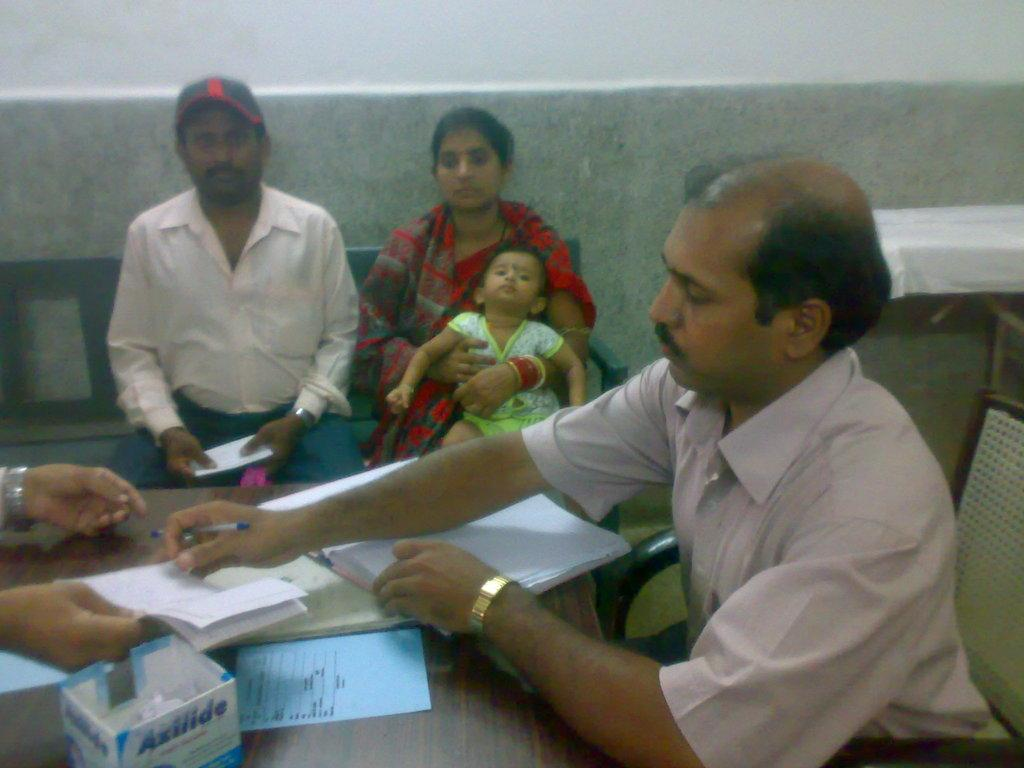What is the man in the image doing? The man is sitting on a chair in the image. Who else is sitting in the image? There is a couple sitting on a bench in the image. Are there any children in the image? Yes, there is a child in the image. What can be seen on the wall in the image? There is a paper on the wall in the image. What is on the table in the image? There is a book on a table in the image. What object related to writing is present in the image? There is a pen in the image. What type of vest is the scarecrow wearing in the image? There is no scarecrow present in the image, so it is not possible to determine what type of vest it might be wearing. --- Facts: 1. There is a car in the image. 2. The car is red. 3. There are people in the car. 4. The car has four wheels. 5. The car has a license plate. Absurd Topics: parrot, sandcastle, telescope Conversation: What is the main subject of the image? The main subject of the image is a car. What color is the car? The car is red. Are there any passengers in the car? Yes, there are people in the car. How many wheels does the car have? The car has four wheels. What is attached to the back of the car for identification purposes? The car has a license plate. Reasoning: Let's think step by step in order to produce the conversation. We start by identifying the main subject in the image, which is the car. Then, we expand the conversation to include the car's color, the presence of passengers, the number of wheels, and the license plate. Each question is designed to elicit a specific detail about the image that is known from the provided facts. Absurd Question/Answer: Can you see a parrot sitting on top of the sandcastle in the image? There is no parrot or sandcastle present in the image, so it is not possible to see them. 